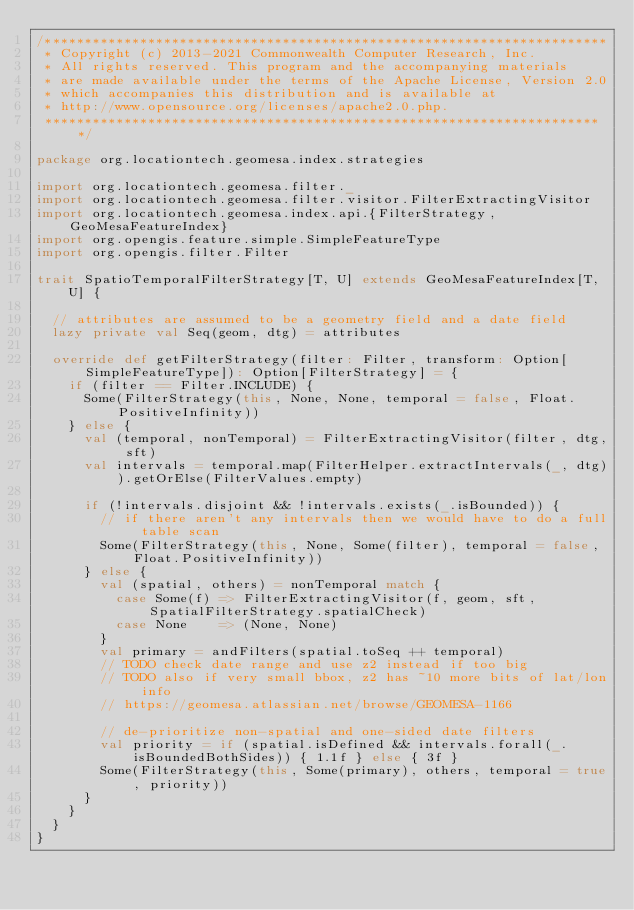Convert code to text. <code><loc_0><loc_0><loc_500><loc_500><_Scala_>/***********************************************************************
 * Copyright (c) 2013-2021 Commonwealth Computer Research, Inc.
 * All rights reserved. This program and the accompanying materials
 * are made available under the terms of the Apache License, Version 2.0
 * which accompanies this distribution and is available at
 * http://www.opensource.org/licenses/apache2.0.php.
 ***********************************************************************/

package org.locationtech.geomesa.index.strategies

import org.locationtech.geomesa.filter._
import org.locationtech.geomesa.filter.visitor.FilterExtractingVisitor
import org.locationtech.geomesa.index.api.{FilterStrategy, GeoMesaFeatureIndex}
import org.opengis.feature.simple.SimpleFeatureType
import org.opengis.filter.Filter

trait SpatioTemporalFilterStrategy[T, U] extends GeoMesaFeatureIndex[T, U] {

  // attributes are assumed to be a geometry field and a date field
  lazy private val Seq(geom, dtg) = attributes

  override def getFilterStrategy(filter: Filter, transform: Option[SimpleFeatureType]): Option[FilterStrategy] = {
    if (filter == Filter.INCLUDE) {
      Some(FilterStrategy(this, None, None, temporal = false, Float.PositiveInfinity))
    } else {
      val (temporal, nonTemporal) = FilterExtractingVisitor(filter, dtg, sft)
      val intervals = temporal.map(FilterHelper.extractIntervals(_, dtg)).getOrElse(FilterValues.empty)

      if (!intervals.disjoint && !intervals.exists(_.isBounded)) {
        // if there aren't any intervals then we would have to do a full table scan
        Some(FilterStrategy(this, None, Some(filter), temporal = false, Float.PositiveInfinity))
      } else {
        val (spatial, others) = nonTemporal match {
          case Some(f) => FilterExtractingVisitor(f, geom, sft, SpatialFilterStrategy.spatialCheck)
          case None    => (None, None)
        }
        val primary = andFilters(spatial.toSeq ++ temporal)
        // TODO check date range and use z2 instead if too big
        // TODO also if very small bbox, z2 has ~10 more bits of lat/lon info
        // https://geomesa.atlassian.net/browse/GEOMESA-1166

        // de-prioritize non-spatial and one-sided date filters
        val priority = if (spatial.isDefined && intervals.forall(_.isBoundedBothSides)) { 1.1f } else { 3f }
        Some(FilterStrategy(this, Some(primary), others, temporal = true, priority))
      }
    }
  }
}
</code> 